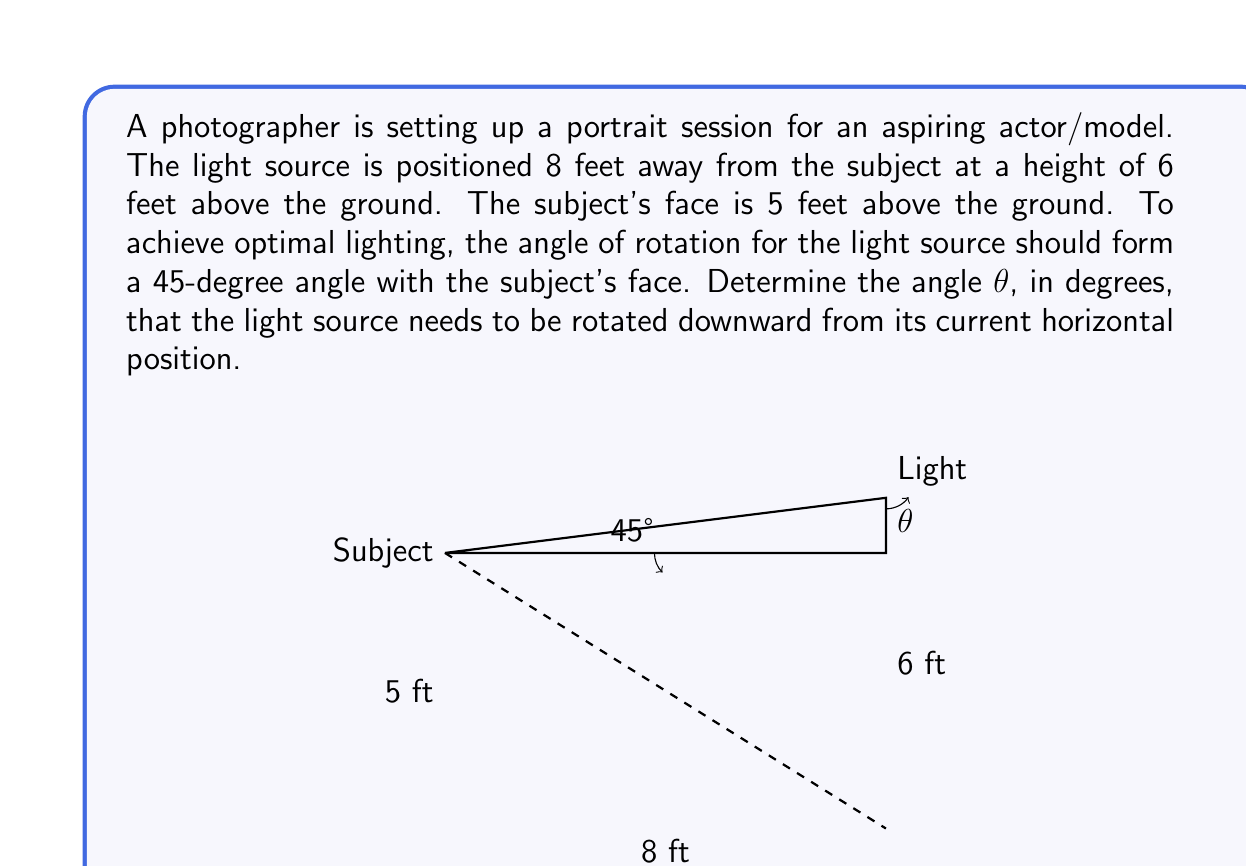Solve this math problem. Let's approach this step-by-step:

1) First, we need to identify the right triangle formed by the light source, the subject's face, and the horizontal line from the light source to the subject.

2) We know:
   - The horizontal distance between the light and subject is 8 feet
   - The height difference between the light and subject is 6 - 5 = 1 foot

3) We can find the current angle of the light to the subject using the arctangent function:
   
   $$\text{Current angle} = \arctan(\frac{1}{8}) \approx 7.125°$$

4) We want the final angle to be 45°. So, we need to rotate the light downward by:

   $$\text{Rotation angle } θ = 45° - 7.125° = 37.875°$$

5) To get a more precise answer, we can use the exact values:

   $$θ = 45° - \arctan(\frac{1}{8})$$

6) Using a calculator or computer algebra system, we can evaluate this to get:

   $$θ \approx 37.875°$$

This is the angle the light needs to be rotated downward from its current horizontal position.
Answer: $45° - \arctan(\frac{1}{8}) \approx 37.875°$ 